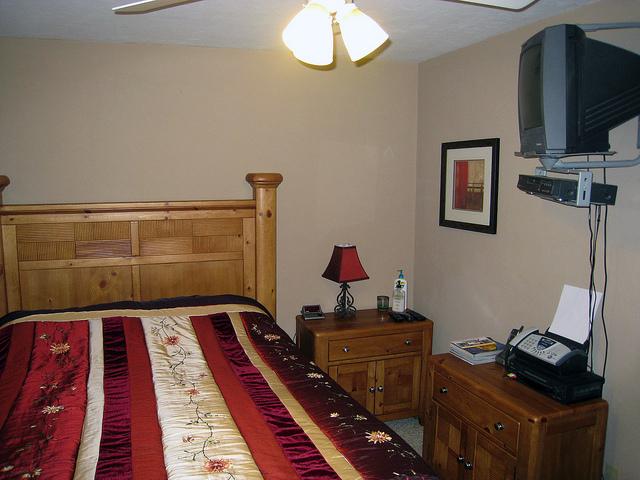Is there a facsimile machine in this picture?
Short answer required. Yes. Is the tv on?
Keep it brief. No. What color is the lamp?
Quick response, please. Red. 